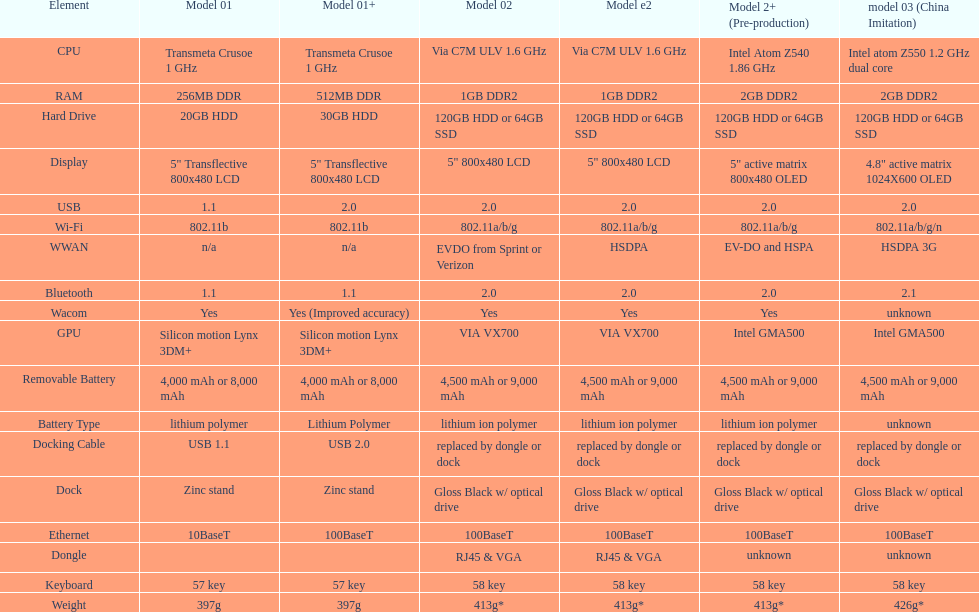How many models utilize a usb docking cable? 2. 